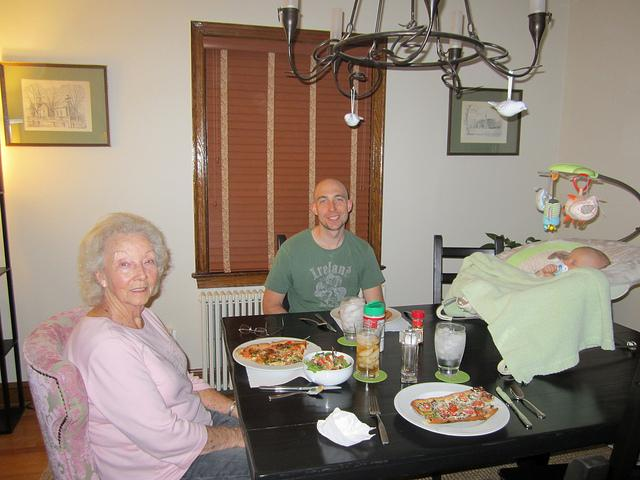What meal are the people most likely eating at the table? Please explain your reasoning. dinner. The people are eating a meal that consists of a flatbread dish and salad. these food items typically would not be served at breakfast or lunch. 